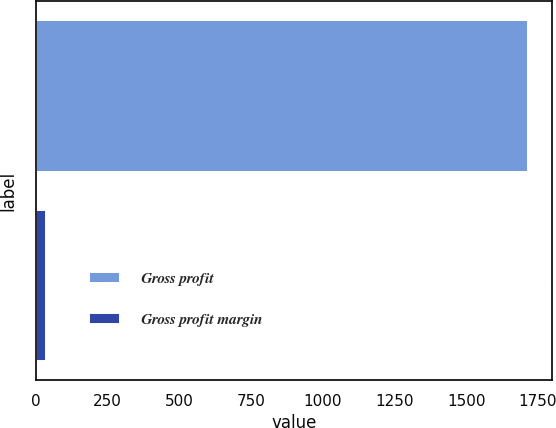Convert chart to OTSL. <chart><loc_0><loc_0><loc_500><loc_500><bar_chart><fcel>Gross profit<fcel>Gross profit margin<nl><fcel>1714.6<fcel>35.2<nl></chart> 